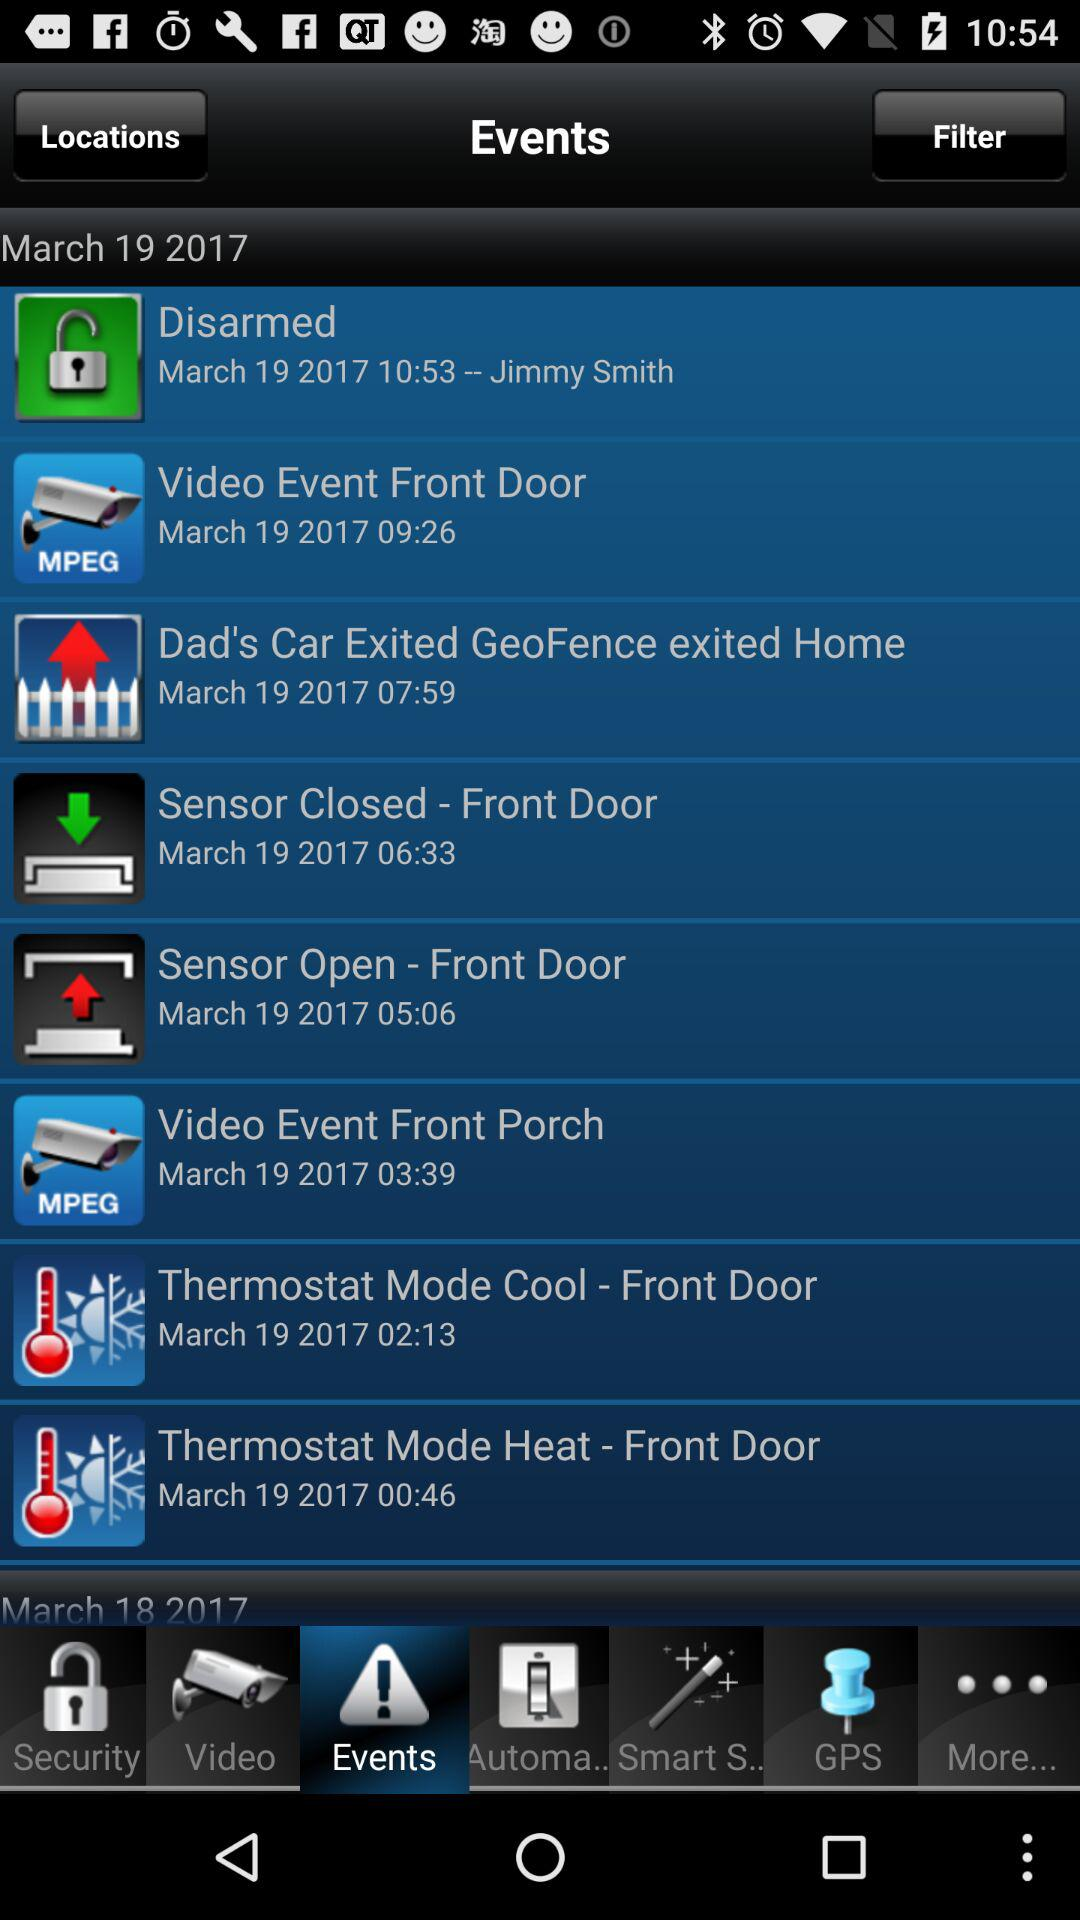What are the events fixed on March 19 2017? The events fixed on March 19, 2017 are: "Disarmed", "Video Event Front Door", "Dad's Car Exited GeoFence exited Home", "Sensor Closed - Front Door", "Sensor Open - Front Door", "Video Event Front Porch", "Thermostat Mode Cool - Front Door", and "Thermostat Mode Heat - Front Door". 